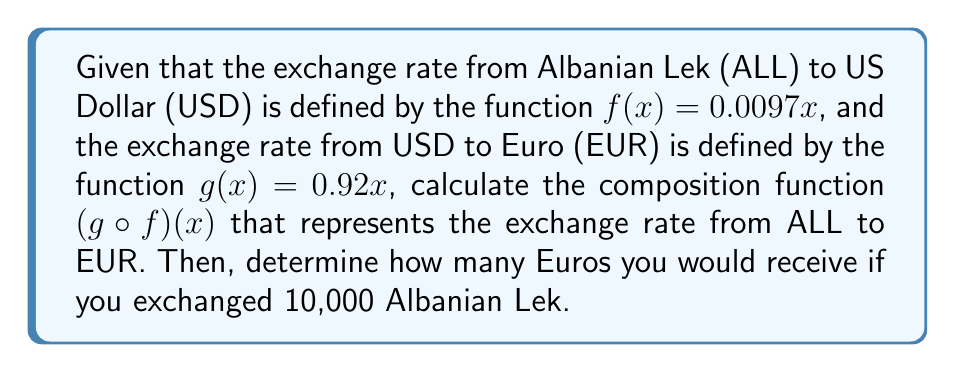Help me with this question. To solve this problem, we need to follow these steps:

1. Find the composition function $(g \circ f)(x)$:
   The composition function is obtained by applying $f$ first, then $g$.
   $$(g \circ f)(x) = g(f(x))$$
   
   Substituting $f(x) = 0.0097x$ into $g(x) = 0.92x$:
   $$(g \circ f)(x) = 0.92(0.0097x)$$

2. Simplify the composition function:
   $$(g \circ f)(x) = 0.92 \cdot 0.0097x = 0.008924x$$

3. To find how many Euros you would receive for 10,000 Albanian Lek, we evaluate the composition function at $x = 10000$:
   $$(g \circ f)(10000) = 0.008924 \cdot 10000 = 89.24$$

Therefore, exchanging 10,000 Albanian Lek would result in 89.24 Euros.
Answer: $(g \circ f)(x) = 0.008924x$; 89.24 EUR 